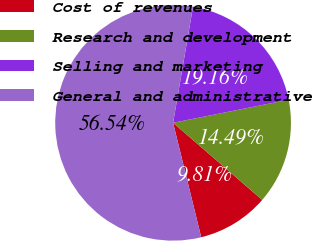Convert chart. <chart><loc_0><loc_0><loc_500><loc_500><pie_chart><fcel>Cost of revenues<fcel>Research and development<fcel>Selling and marketing<fcel>General and administrative<nl><fcel>9.81%<fcel>14.49%<fcel>19.16%<fcel>56.54%<nl></chart> 